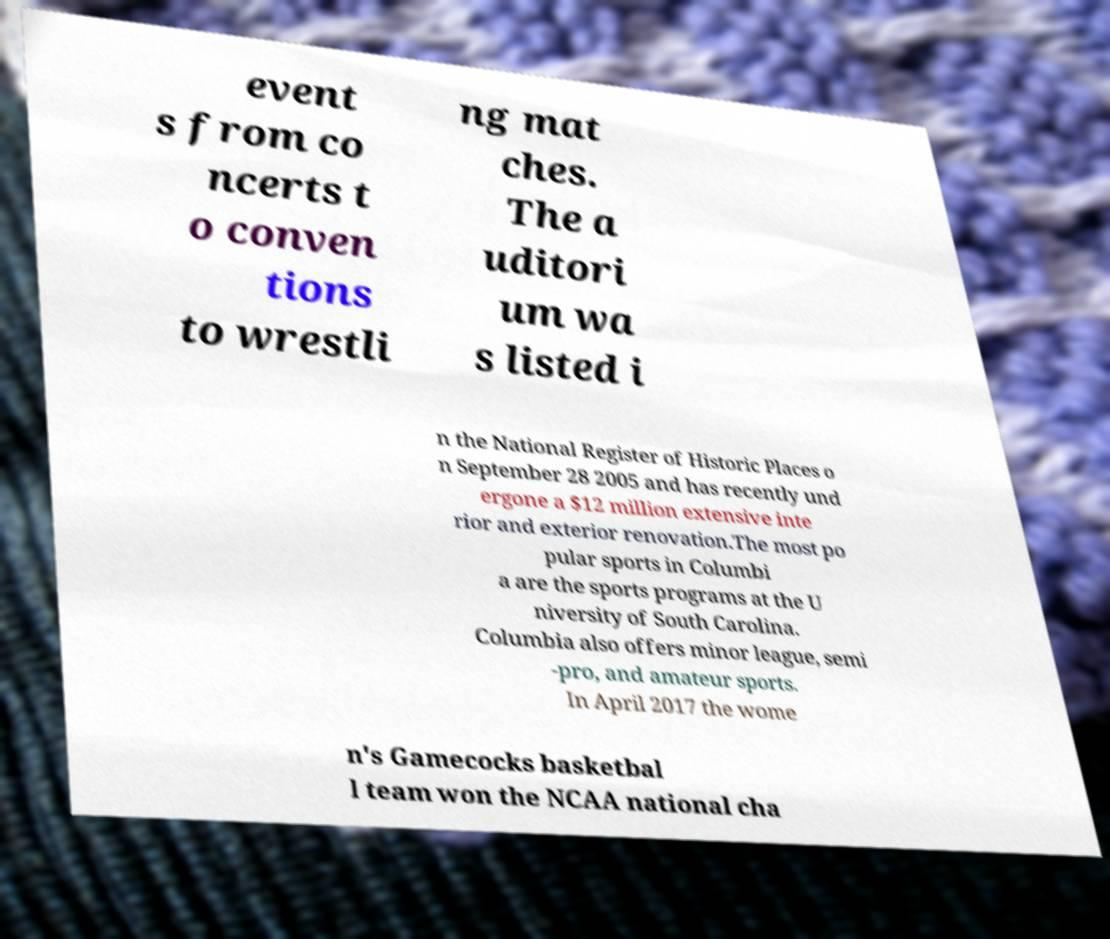Please identify and transcribe the text found in this image. event s from co ncerts t o conven tions to wrestli ng mat ches. The a uditori um wa s listed i n the National Register of Historic Places o n September 28 2005 and has recently und ergone a $12 million extensive inte rior and exterior renovation.The most po pular sports in Columbi a are the sports programs at the U niversity of South Carolina. Columbia also offers minor league, semi -pro, and amateur sports. In April 2017 the wome n's Gamecocks basketbal l team won the NCAA national cha 